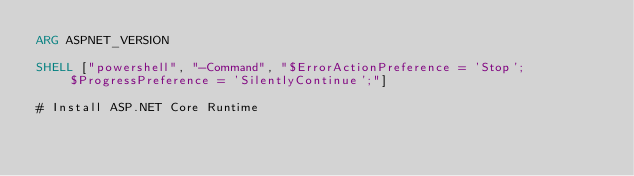<code> <loc_0><loc_0><loc_500><loc_500><_Dockerfile_>ARG ASPNET_VERSION

SHELL ["powershell", "-Command", "$ErrorActionPreference = 'Stop'; $ProgressPreference = 'SilentlyContinue';"]

# Install ASP.NET Core Runtime</code> 